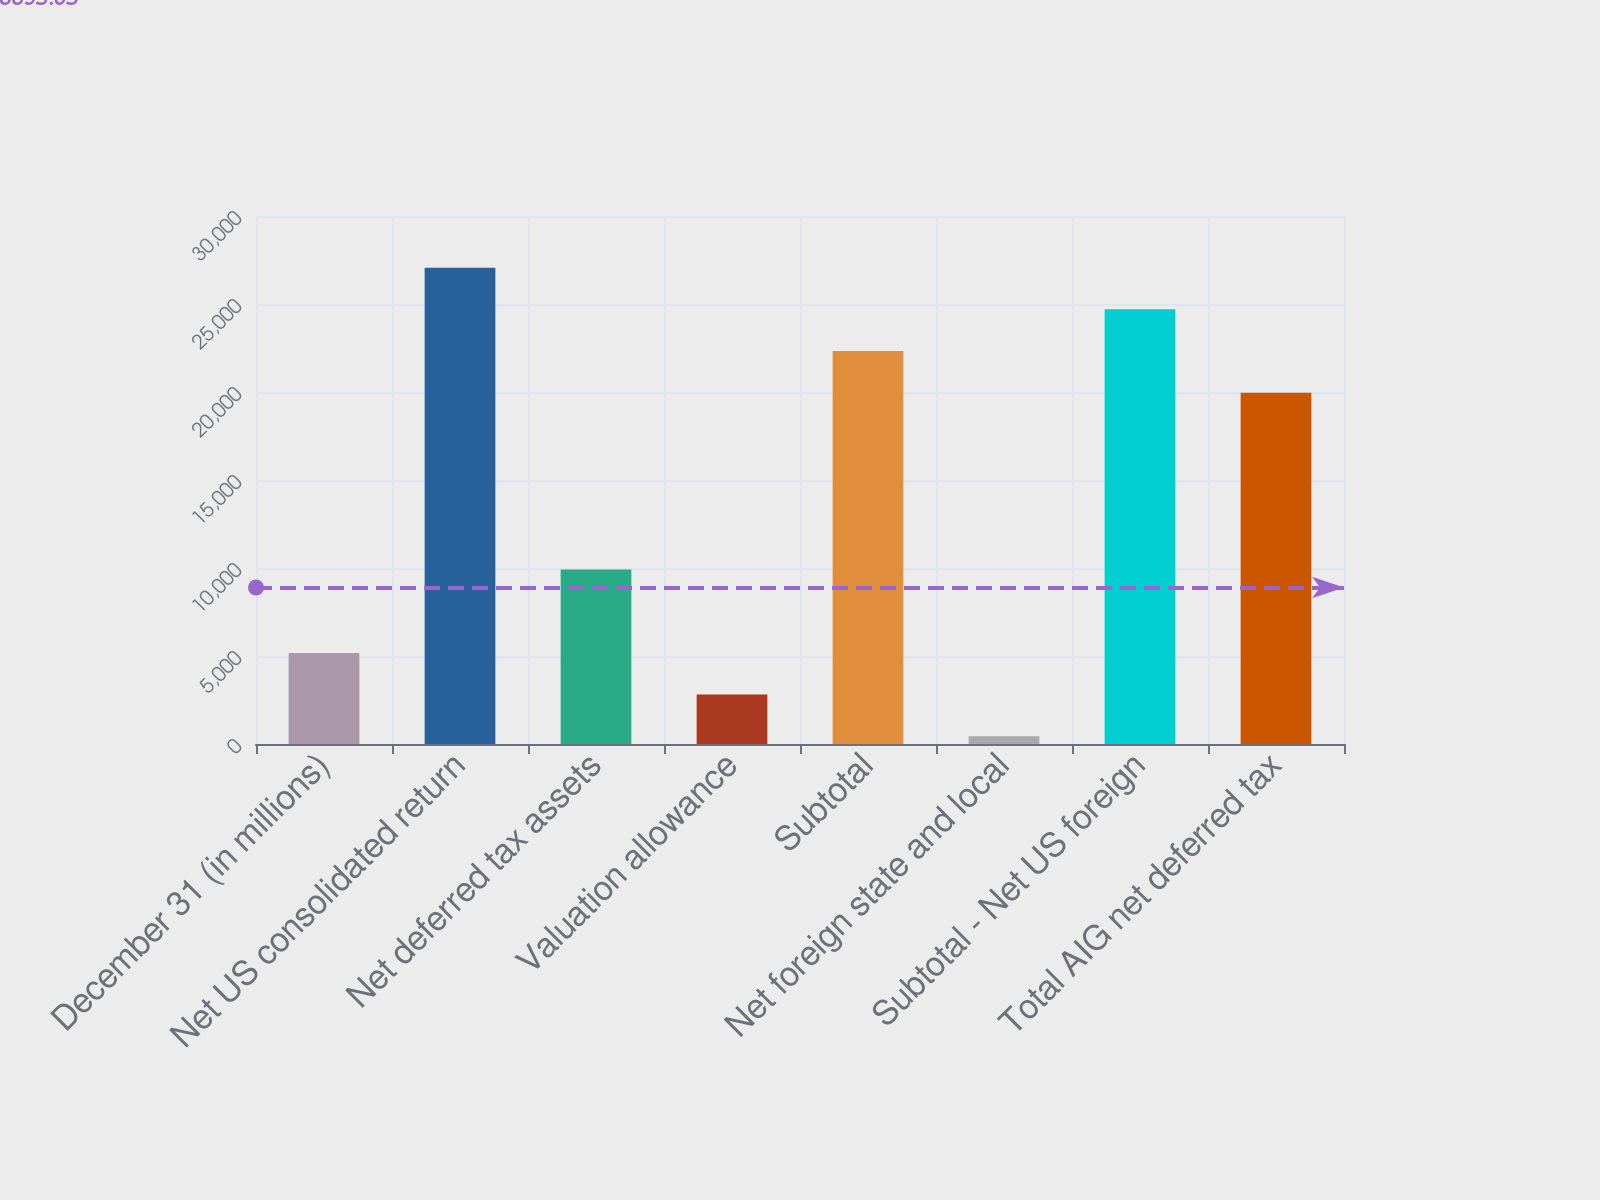<chart> <loc_0><loc_0><loc_500><loc_500><bar_chart><fcel>December 31 (in millions)<fcel>Net US consolidated return<fcel>Net deferred tax assets<fcel>Valuation allowance<fcel>Subtotal<fcel>Net foreign state and local<fcel>Subtotal - Net US foreign<fcel>Total AIG net deferred tax<nl><fcel>5176.4<fcel>27066.1<fcel>9915.8<fcel>2806.7<fcel>22326.7<fcel>437<fcel>24696.4<fcel>19957<nl></chart> 